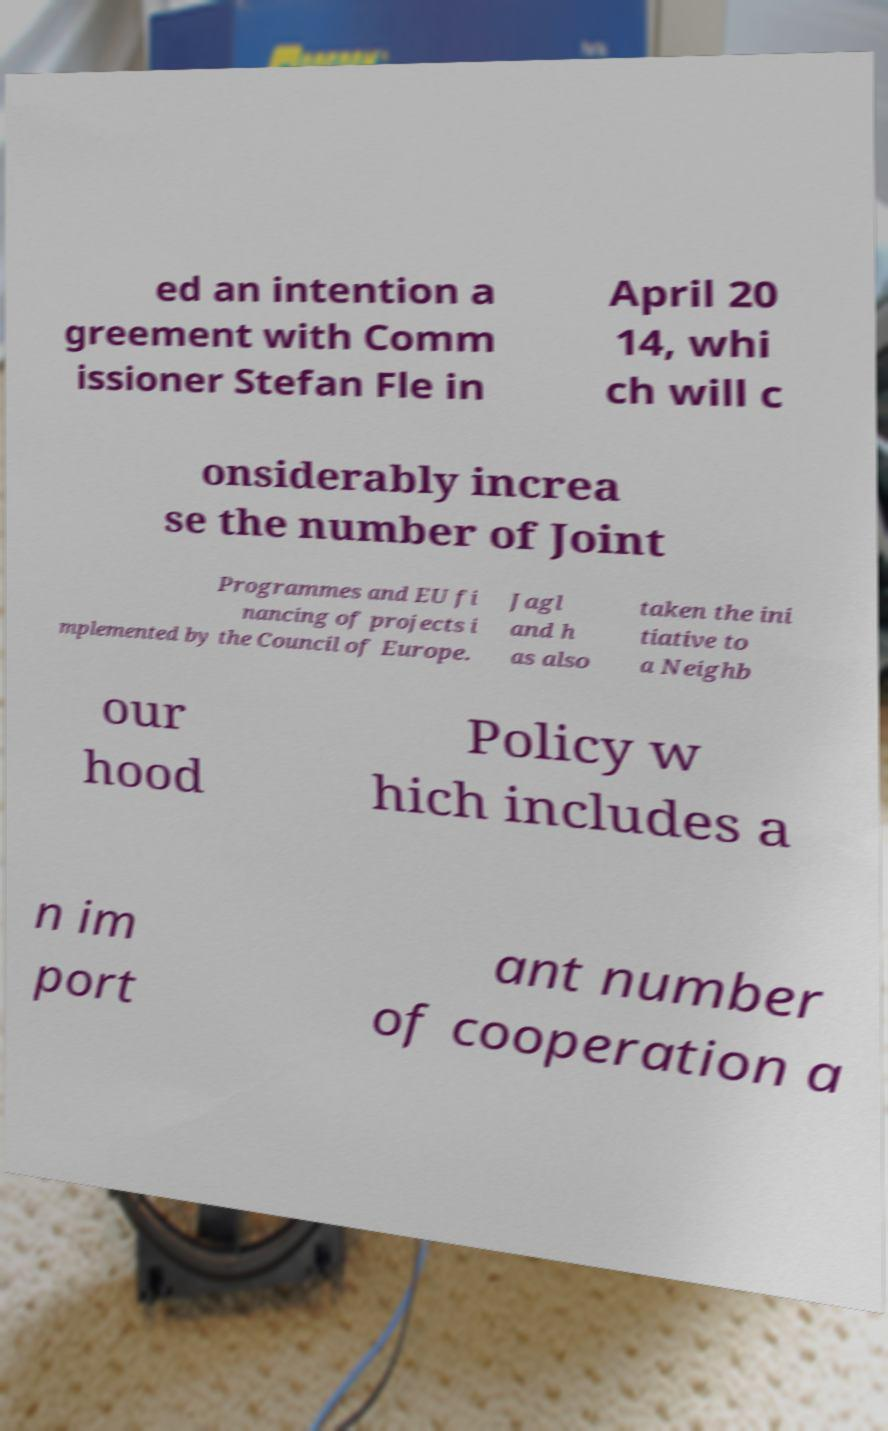Could you extract and type out the text from this image? ed an intention a greement with Comm issioner Stefan Fle in April 20 14, whi ch will c onsiderably increa se the number of Joint Programmes and EU fi nancing of projects i mplemented by the Council of Europe. Jagl and h as also taken the ini tiative to a Neighb our hood Policy w hich includes a n im port ant number of cooperation a 